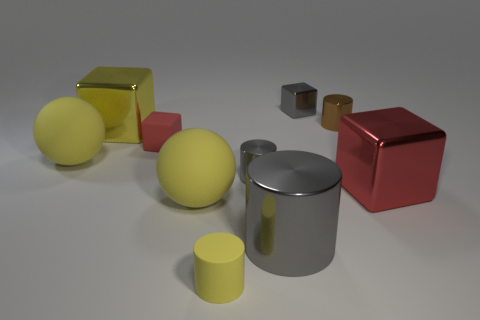There is a metallic block left of the matte block; is it the same size as the small yellow cylinder?
Offer a very short reply. No. What is the size of the thing that is behind the small red matte block and to the left of the small gray metallic cylinder?
Your response must be concise. Large. There is another cylinder that is the same color as the big metallic cylinder; what is it made of?
Ensure brevity in your answer.  Metal. How many tiny shiny objects are the same color as the tiny matte cylinder?
Your response must be concise. 0. Are there the same number of big metallic things that are in front of the small yellow cylinder and big yellow spheres?
Your response must be concise. No. What color is the small matte cylinder?
Offer a very short reply. Yellow. There is a brown thing that is the same material as the large red cube; what size is it?
Provide a succinct answer. Small. What color is the large cylinder that is the same material as the small brown cylinder?
Make the answer very short. Gray. Are there any red shiny cylinders that have the same size as the yellow shiny block?
Offer a very short reply. No. There is another large thing that is the same shape as the yellow metal thing; what is it made of?
Ensure brevity in your answer.  Metal. 